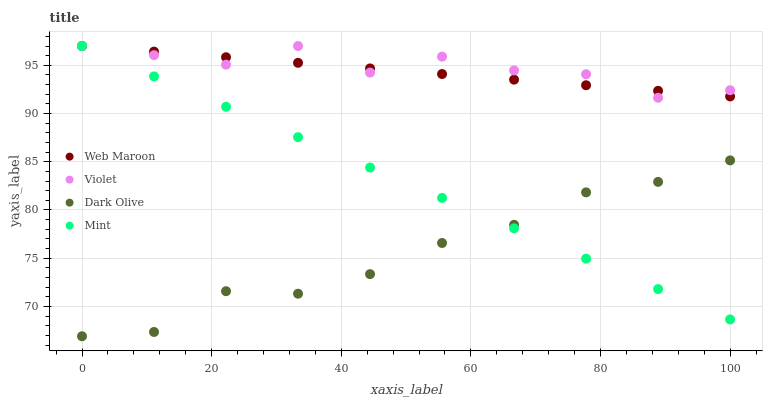Does Dark Olive have the minimum area under the curve?
Answer yes or no. Yes. Does Violet have the maximum area under the curve?
Answer yes or no. Yes. Does Web Maroon have the minimum area under the curve?
Answer yes or no. No. Does Web Maroon have the maximum area under the curve?
Answer yes or no. No. Is Web Maroon the smoothest?
Answer yes or no. Yes. Is Violet the roughest?
Answer yes or no. Yes. Is Dark Olive the smoothest?
Answer yes or no. No. Is Dark Olive the roughest?
Answer yes or no. No. Does Dark Olive have the lowest value?
Answer yes or no. Yes. Does Web Maroon have the lowest value?
Answer yes or no. No. Does Violet have the highest value?
Answer yes or no. Yes. Does Dark Olive have the highest value?
Answer yes or no. No. Is Dark Olive less than Violet?
Answer yes or no. Yes. Is Web Maroon greater than Dark Olive?
Answer yes or no. Yes. Does Mint intersect Violet?
Answer yes or no. Yes. Is Mint less than Violet?
Answer yes or no. No. Is Mint greater than Violet?
Answer yes or no. No. Does Dark Olive intersect Violet?
Answer yes or no. No. 